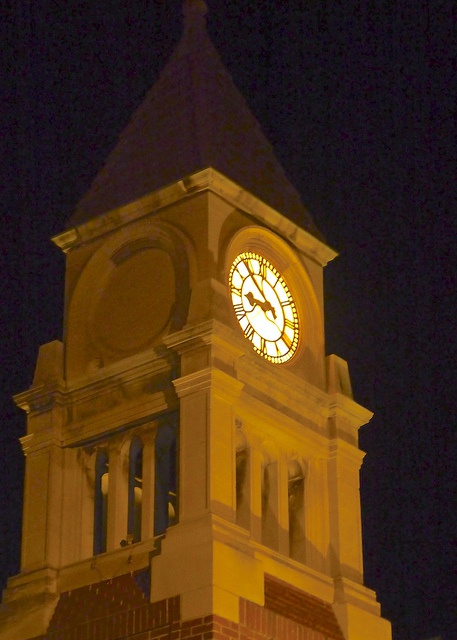Describe the objects in this image and their specific colors. I can see a clock in black, ivory, red, orange, and khaki tones in this image. 